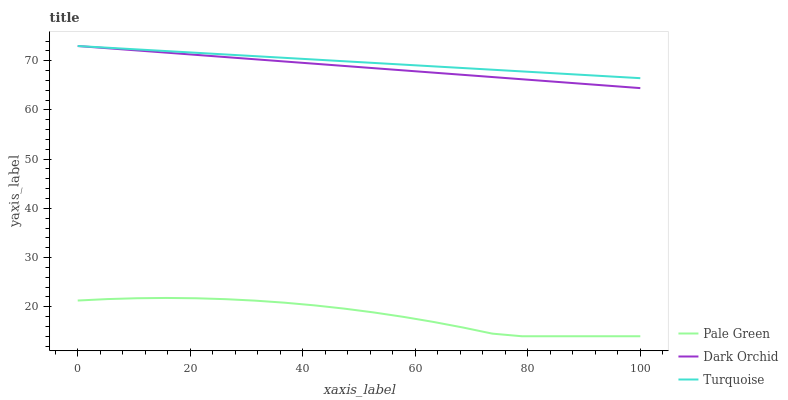Does Pale Green have the minimum area under the curve?
Answer yes or no. Yes. Does Turquoise have the maximum area under the curve?
Answer yes or no. Yes. Does Dark Orchid have the minimum area under the curve?
Answer yes or no. No. Does Dark Orchid have the maximum area under the curve?
Answer yes or no. No. Is Turquoise the smoothest?
Answer yes or no. Yes. Is Pale Green the roughest?
Answer yes or no. Yes. Is Dark Orchid the smoothest?
Answer yes or no. No. Is Dark Orchid the roughest?
Answer yes or no. No. Does Pale Green have the lowest value?
Answer yes or no. Yes. Does Dark Orchid have the lowest value?
Answer yes or no. No. Does Dark Orchid have the highest value?
Answer yes or no. Yes. Does Pale Green have the highest value?
Answer yes or no. No. Is Pale Green less than Dark Orchid?
Answer yes or no. Yes. Is Dark Orchid greater than Pale Green?
Answer yes or no. Yes. Does Dark Orchid intersect Turquoise?
Answer yes or no. Yes. Is Dark Orchid less than Turquoise?
Answer yes or no. No. Is Dark Orchid greater than Turquoise?
Answer yes or no. No. Does Pale Green intersect Dark Orchid?
Answer yes or no. No. 